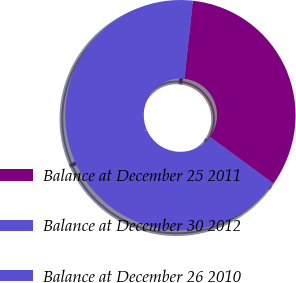Convert chart to OTSL. <chart><loc_0><loc_0><loc_500><loc_500><pie_chart><fcel>Balance at December 25 2011<fcel>Balance at December 30 2012<fcel>Balance at December 26 2010<nl><fcel>33.33%<fcel>33.33%<fcel>33.33%<nl></chart> 